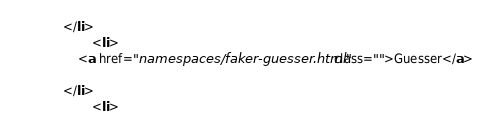Convert code to text. <code><loc_0><loc_0><loc_500><loc_500><_HTML_>            </li>
                    <li>
                <a href="namespaces/faker-guesser.html" class="">Guesser</a>
                
            </li>
                    <li></code> 